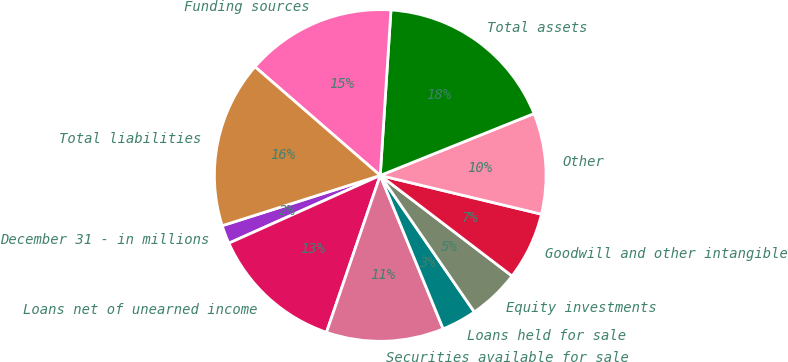Convert chart to OTSL. <chart><loc_0><loc_0><loc_500><loc_500><pie_chart><fcel>December 31 - in millions<fcel>Loans net of unearned income<fcel>Securities available for sale<fcel>Loans held for sale<fcel>Equity investments<fcel>Goodwill and other intangible<fcel>Other<fcel>Total assets<fcel>Funding sources<fcel>Total liabilities<nl><fcel>1.8%<fcel>13.05%<fcel>11.45%<fcel>3.41%<fcel>5.02%<fcel>6.62%<fcel>9.84%<fcel>17.88%<fcel>14.66%<fcel>16.27%<nl></chart> 